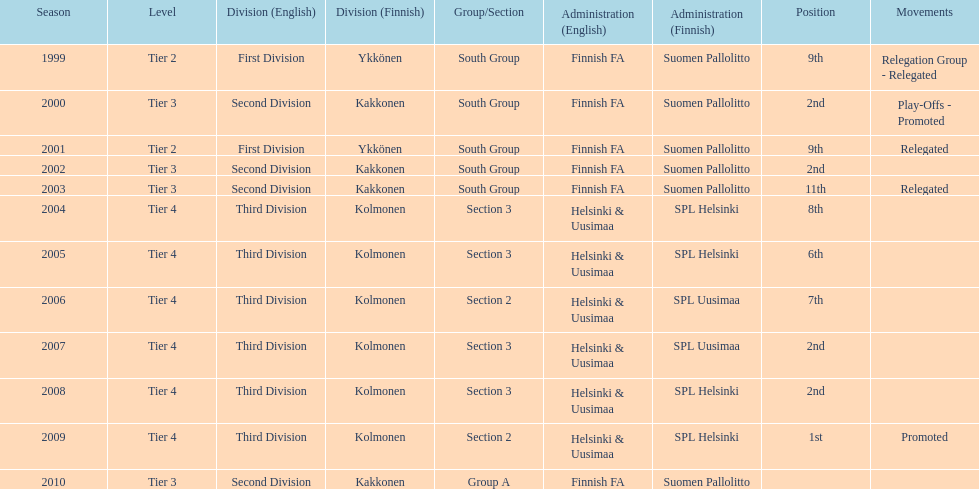What division were they in the most, section 3 or 2? 3. 